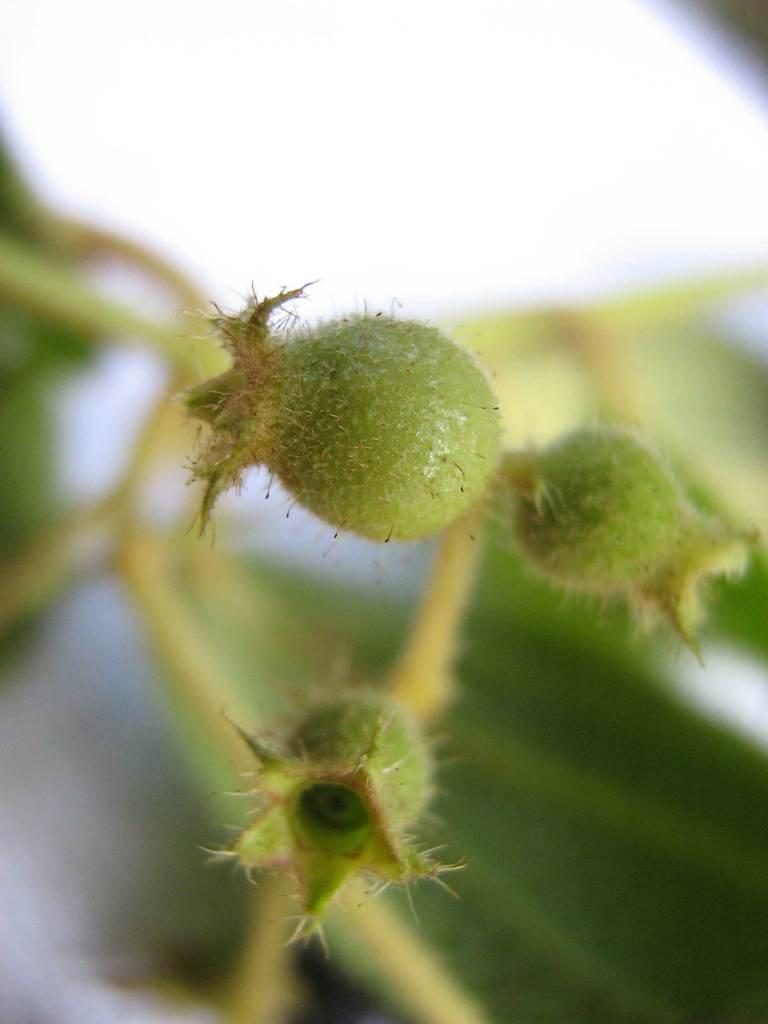What is present in the image? There is a plant in the image. Can you describe the plant's current state? The plant has buds. What can be observed about the background of the image? The background of the image is blurred. What type of waste is visible in the image? There is no waste present in the image; it features a plant with buds. Can you tell me how many sisters are visible in the image? There are no people, let alone sisters, present in the image. 